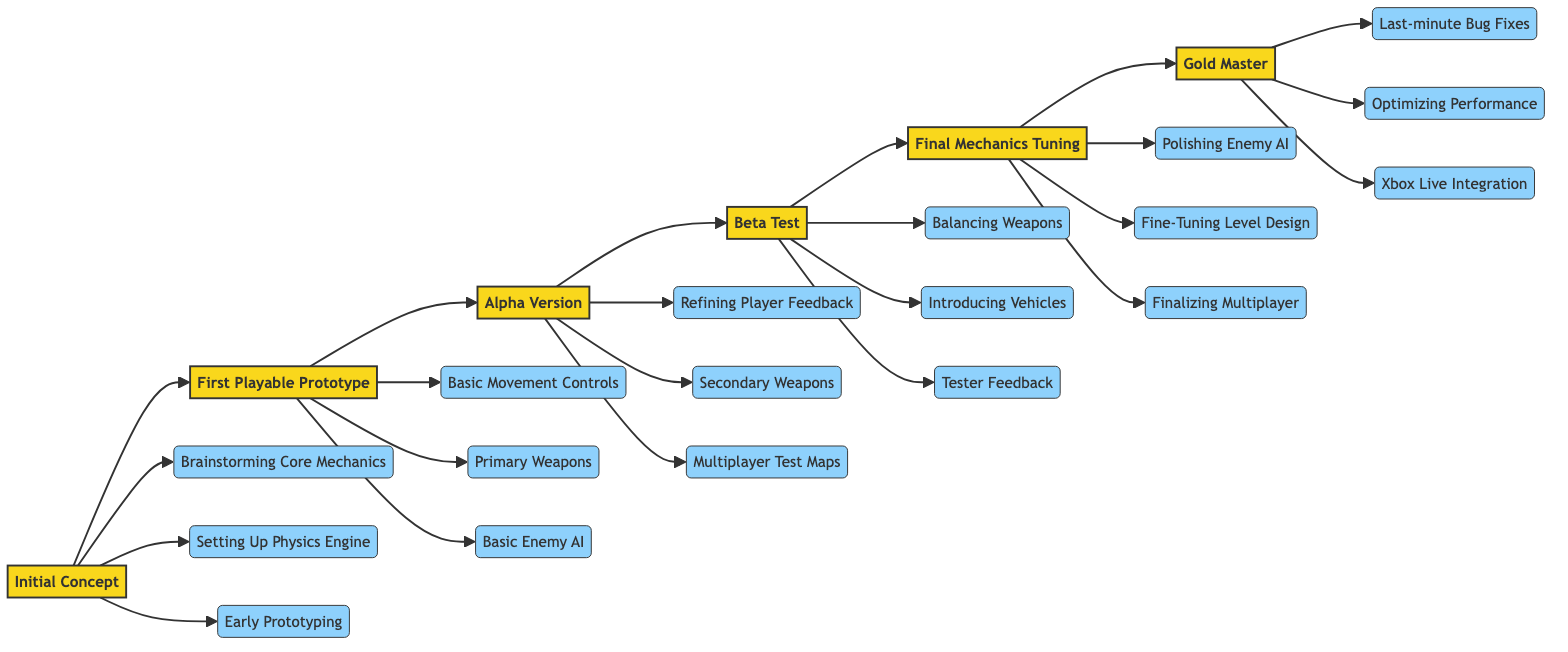What's the first phase in the evolution of the Halo combat system? The diagram starts with the "Initial Concept" phase, which is indicated as the first node in the flowchart.
Answer: Initial Concept How many key elements are associated with the "Beta Test" phase? The "Beta Test" phase has three key elements listed: balancing weapon damage and rates of fire, introducing vehicles, and feedback incorporation from testers. Therefore, the count is three.
Answer: 3 What is the last phase before reaching the "Gold Master"? The flowchart shows that the last phase before "Gold Master" is "Final Mechanics Tuning," which is directly connected to it in the sequence.
Answer: Final Mechanics Tuning Which key element is linked to the "Alpha Version"? The diagram connects three key elements to the "Alpha Version": refining player feedback mechanics, adding secondary weapons, and implementing multiplayer test maps. All are distinct, but one example is enough for the answer.
Answer: Refining Player Feedback Mechanics What links the "Initial Concept" and "First Playable Prototype" phases? The relationship between the two phases is a direct flow connection; "Initial Concept" leads straight to "First Playable Prototype." There are no intermediate nodes between them.
Answer: Direct flow connection 